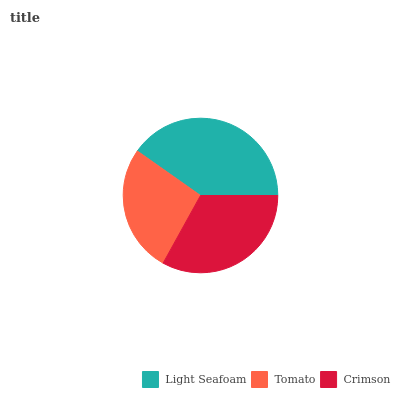Is Tomato the minimum?
Answer yes or no. Yes. Is Light Seafoam the maximum?
Answer yes or no. Yes. Is Crimson the minimum?
Answer yes or no. No. Is Crimson the maximum?
Answer yes or no. No. Is Crimson greater than Tomato?
Answer yes or no. Yes. Is Tomato less than Crimson?
Answer yes or no. Yes. Is Tomato greater than Crimson?
Answer yes or no. No. Is Crimson less than Tomato?
Answer yes or no. No. Is Crimson the high median?
Answer yes or no. Yes. Is Crimson the low median?
Answer yes or no. Yes. Is Light Seafoam the high median?
Answer yes or no. No. Is Light Seafoam the low median?
Answer yes or no. No. 